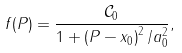Convert formula to latex. <formula><loc_0><loc_0><loc_500><loc_500>f ( P ) = \frac { \mathcal { C } _ { 0 } } { 1 + \left ( P - x _ { 0 } \right ) ^ { 2 } / a ^ { 2 } _ { 0 } } ,</formula> 